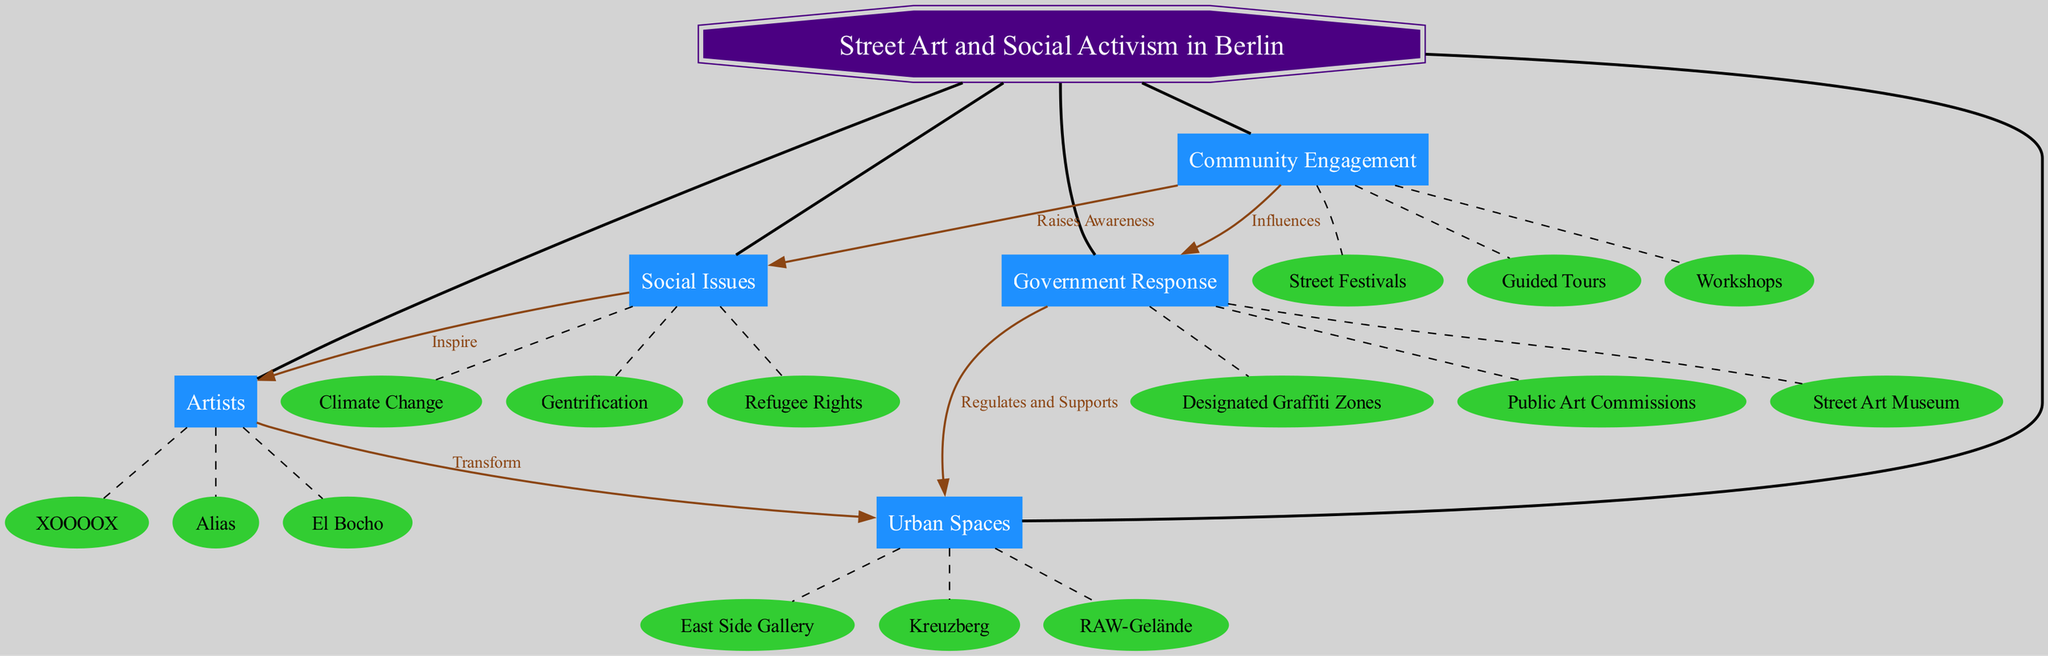What is the central concept of the diagram? The central concept is explicitly labeled at the top of the diagram, which is "Street Art and Social Activism in Berlin."
Answer: Street Art and Social Activism in Berlin How many main nodes are there? By counting the nodes that directly connect to the central concept, we see that there are five main nodes.
Answer: 5 Which artist is connected to urban spaces? The connections show that artists transform urban spaces, and the specific artists listed as sub-nodes include "El Bocho," "XOOOOX," and "Alias."
Answer: El Bocho, XOOOOX, Alias What social issues are connected to the artists? The diagram indicates that artists are inspired by social issues, and the sub-nodes under social issues include "Gentrification," "Refugee Rights," and "Climate Change."
Answer: Gentrification, Refugee Rights, Climate Change How do community engagement activities affect social issues? According to the diagram, community engagement activities raise awareness about social issues, which indicates a direct positive influence on understanding those issues.
Answer: Raises Awareness Which urban space is associated with government response? The connections state that government response regulates and supports urban spaces, and the urban spaces listed include "East Side Gallery," "Kreuzberg," and "RAW-Gelände."
Answer: East Side Gallery, Kreuzberg, RAW-Gelände What type of community engagement activity is indicated in the diagram? The community engagement main node leads to sub-nodes such as "Workshops," "Street Festivals," and "Guided Tours," indicating the types of activities present.
Answer: Workshops, Street Festivals, Guided Tours How does government response influence community engagement? The connections in the diagram show that government response influences community engagement initiatives, suggesting a reciprocal relationship between these two elements.
Answer: Influences Which issue is not represented in the social issues node? The social issues node includes three specific sub-nodes and does not contain any mention of issues such as poverty or education, indicating their absence.
Answer: Poverty, Education 